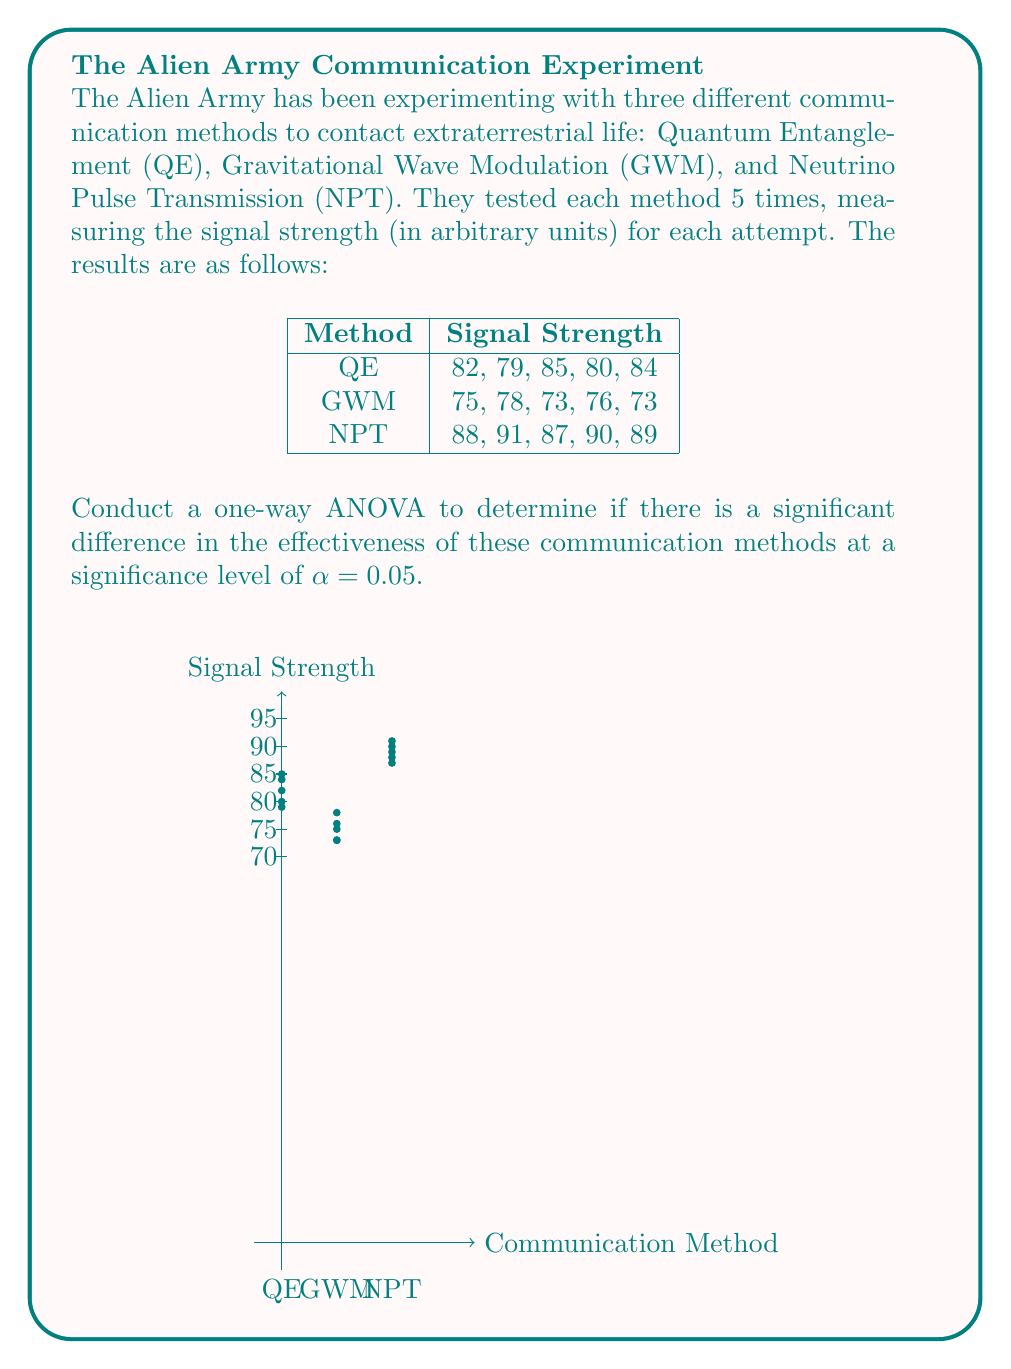Help me with this question. To conduct a one-way ANOVA, we'll follow these steps:

1. Calculate the sum of squares between groups (SSB) and within groups (SSW).
2. Calculate the degrees of freedom for between groups (dfB) and within groups (dfW).
3. Calculate the mean squares for between groups (MSB) and within groups (MSW).
4. Calculate the F-statistic.
5. Compare the F-statistic to the critical F-value.

Step 1: Calculate SSB and SSW

First, we need to calculate the grand mean:
$$\bar{X} = \frac{82+79+85+80+84+75+78+73+76+73+88+91+87+90+89}{15} = 82$$

Now, we calculate the sum of squares between groups (SSB):
$$SSB = 5[(82-82)^2 + (75-82)^2 + (89-82)^2] = 630$$

For SSW, we calculate the sum of squared deviations within each group:
$$SSW_{QE} = (82-82)^2 + (79-82)^2 + (85-82)^2 + (80-82)^2 + (84-82)^2 = 30$$
$$SSW_{GWM} = (75-75)^2 + (78-75)^2 + (73-75)^2 + (76-75)^2 + (73-75)^2 = 20$$
$$SSW_{NPT} = (88-89)^2 + (91-89)^2 + (87-89)^2 + (90-89)^2 + (89-89)^2 = 10$$

$$SSW = SSW_{QE} + SSW_{GWM} + SSW_{NPT} = 30 + 20 + 10 = 60$$

Step 2: Calculate degrees of freedom

$$df_B = k - 1 = 3 - 1 = 2$$ (where k is the number of groups)
$$df_W = N - k = 15 - 3 = 12$$ (where N is the total number of observations)

Step 3: Calculate mean squares

$$MSB = \frac{SSB}{df_B} = \frac{630}{2} = 315$$
$$MSW = \frac{SSW}{df_W} = \frac{60}{12} = 5$$

Step 4: Calculate F-statistic

$$F = \frac{MSB}{MSW} = \frac{315}{5} = 63$$

Step 5: Compare to critical F-value

The critical F-value for α = 0.05, df_B = 2, and df_W = 12 is approximately 3.89.

Since our calculated F-statistic (63) is greater than the critical F-value (3.89), we reject the null hypothesis.
Answer: F(2,12) = 63, p < 0.05. Significant difference exists. 